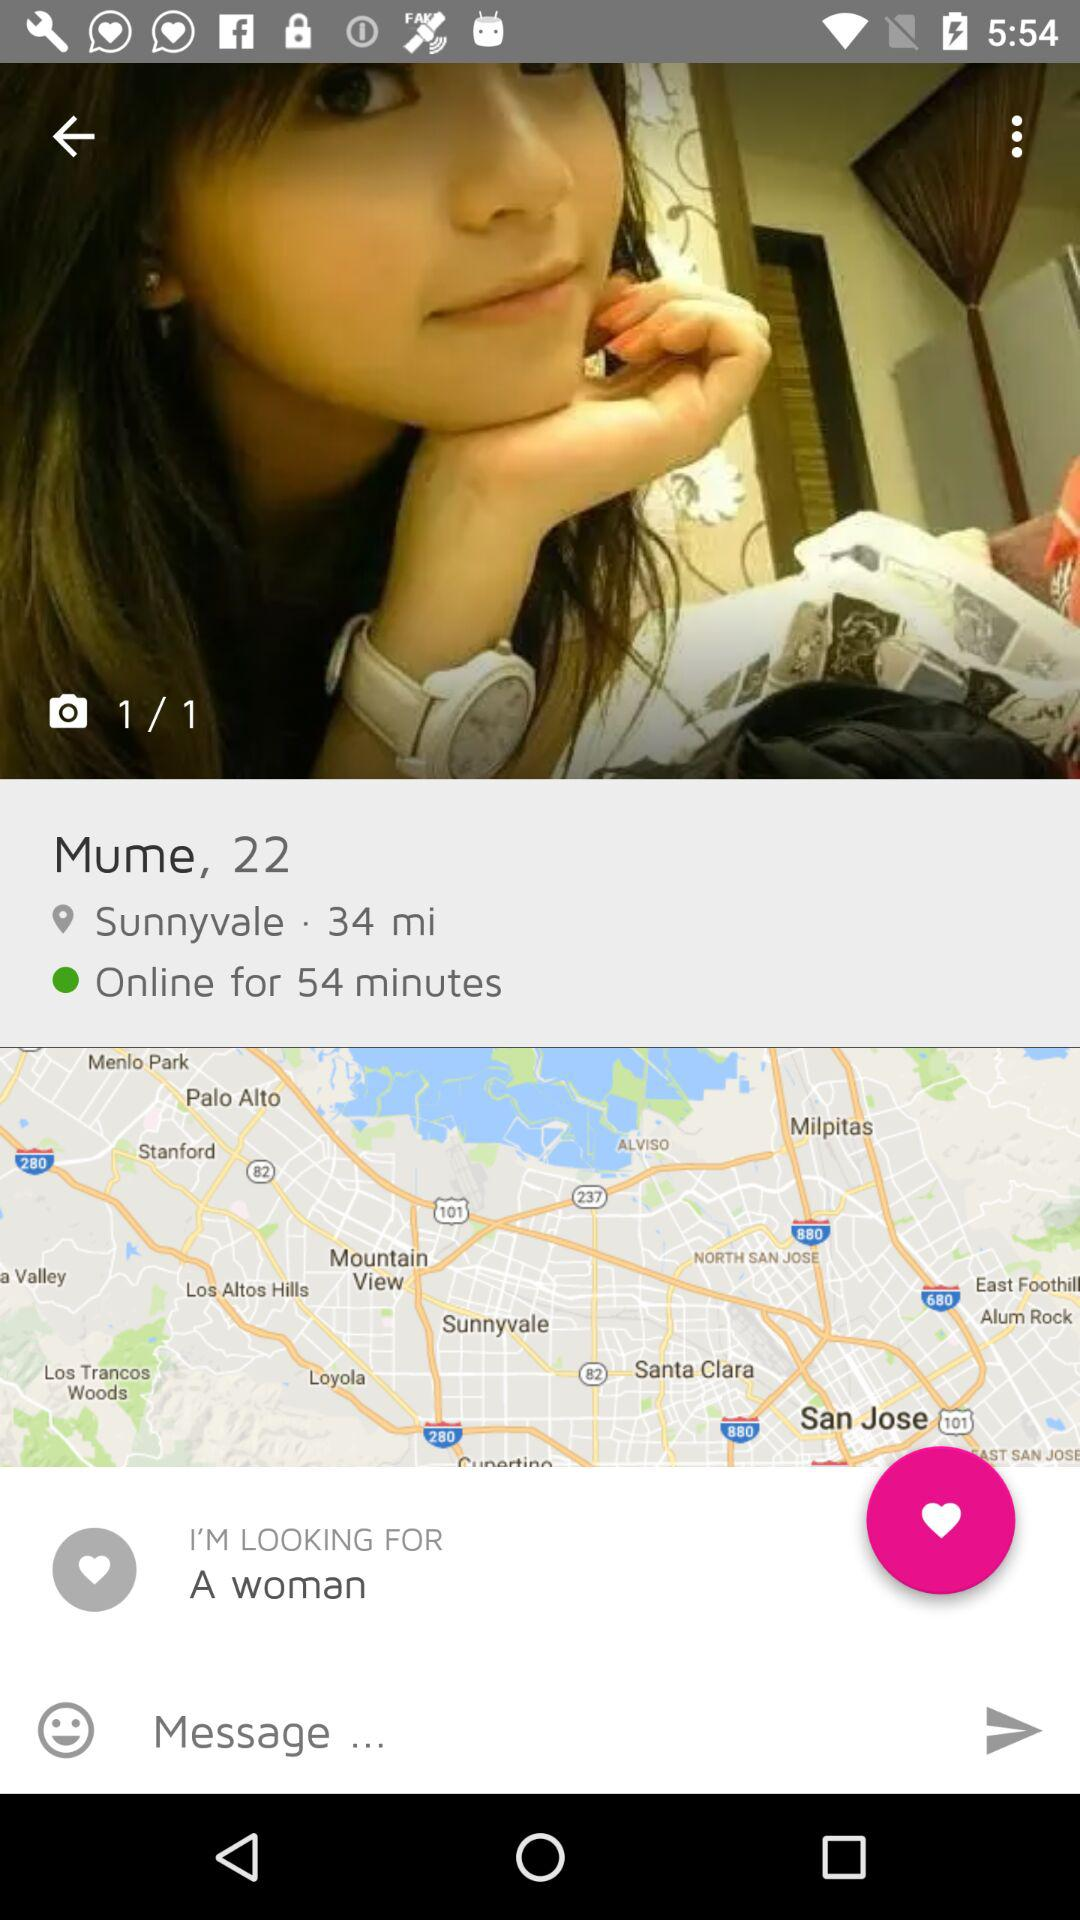What is the user looking for? The user is looking for a woman. 